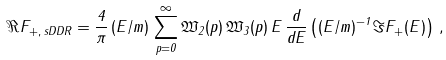<formula> <loc_0><loc_0><loc_500><loc_500>\Re F _ { + , \, s D D R } = \frac { 4 } { \pi } \, ( E / m ) \, \sum _ { p = 0 } ^ { \infty } \mathfrak { W } _ { 2 } ( p ) \, \mathfrak { W } _ { 3 } ( p ) \, E \, \frac { d } { d E } \left ( ( E / m ) ^ { - 1 } \, \Im F _ { + } ( E ) \right ) \, ,</formula> 